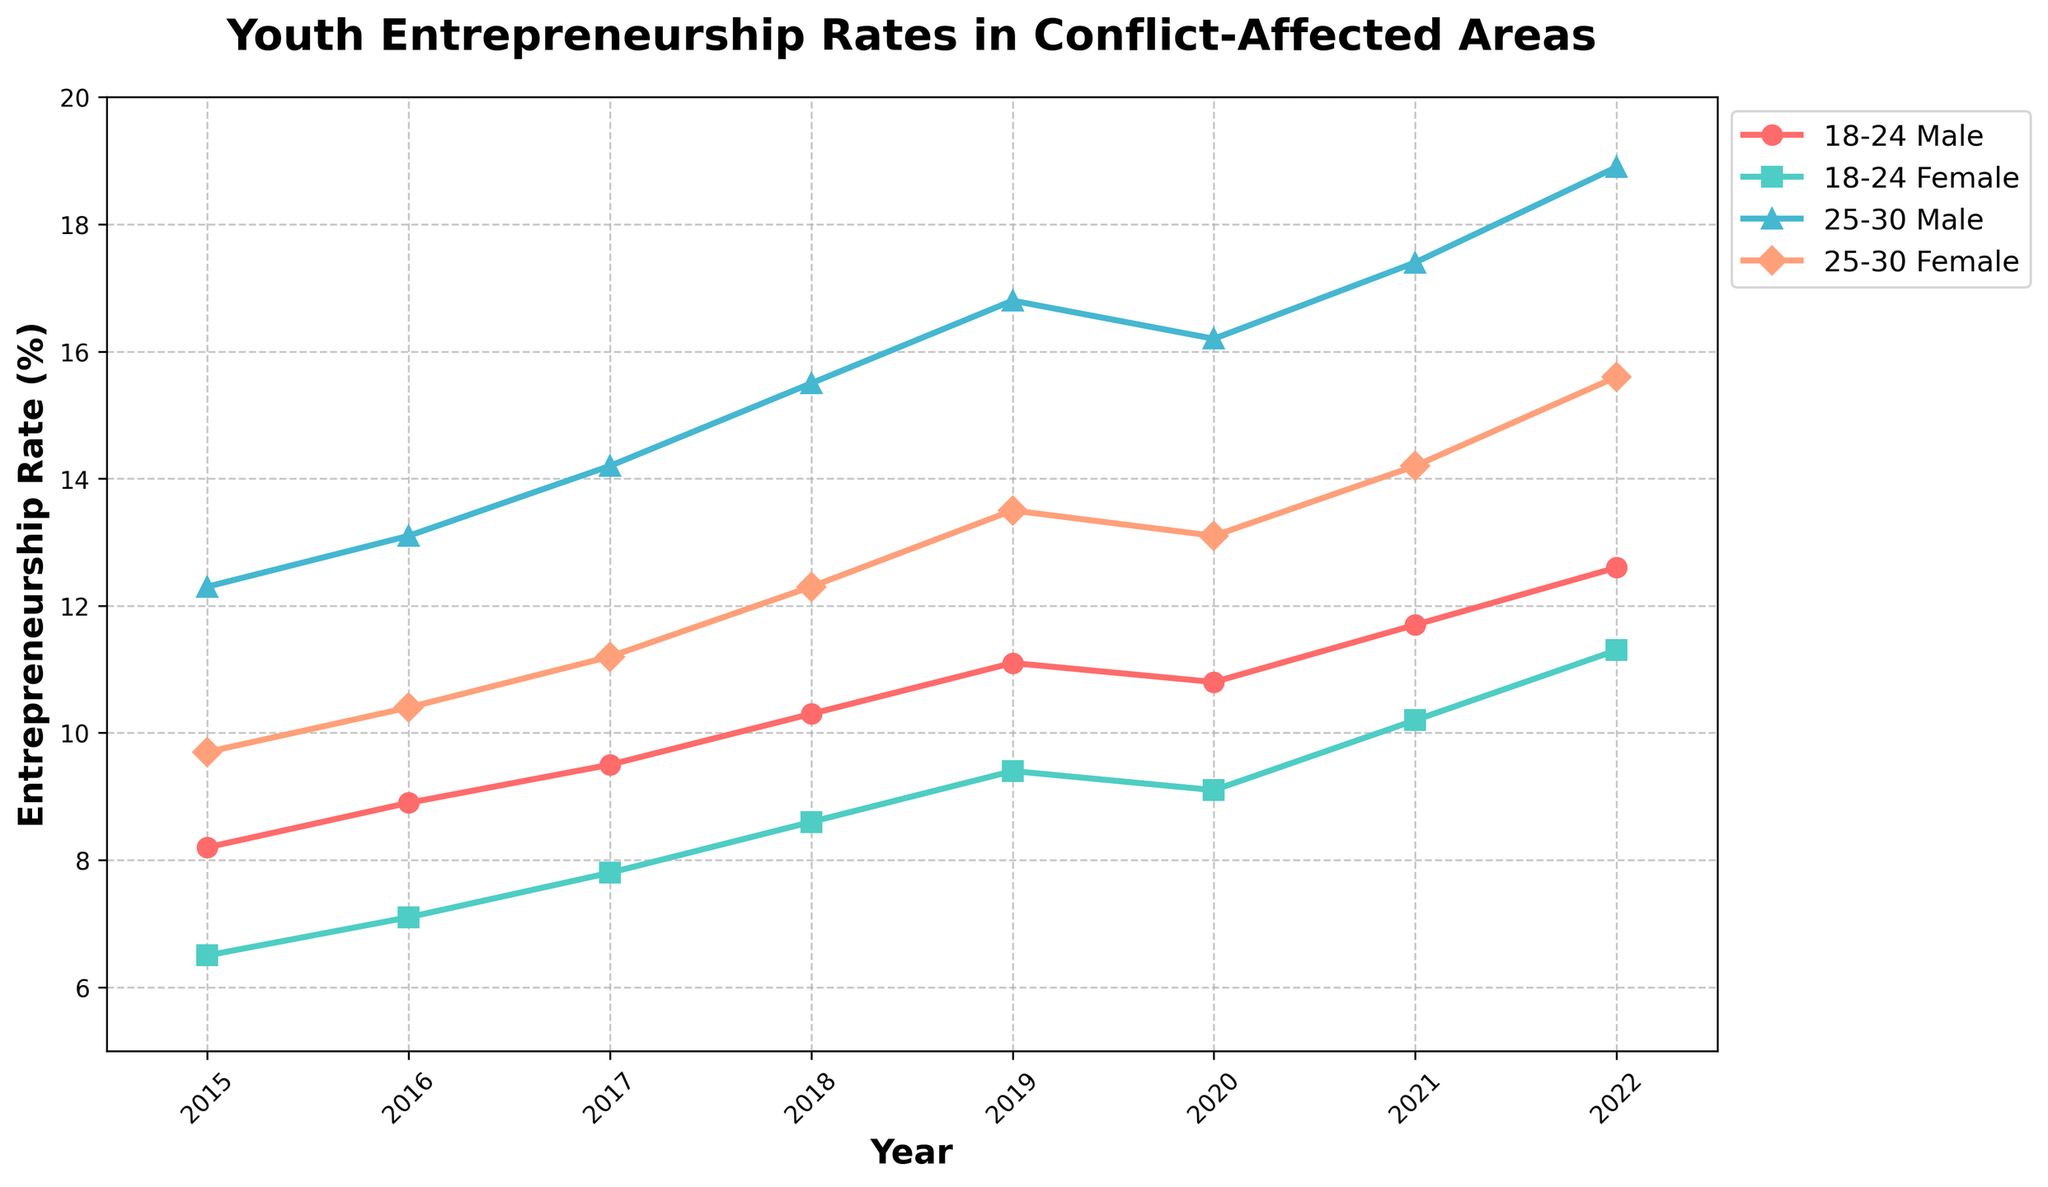What's the overall trend for male entrepreneurs aged 18-24 from 2015 to 2022? To answer this question, observe the line corresponding to "18-24 Male" from 2015 to 2022. It starts at 8.2 in 2015 and ends at 12.6 in 2022 with a general upward trend, despite a slight dip in 2020.
Answer: Upward trend In which year did 25-30 Female see the highest entrepreneurship rate? Look at the "25-30 Female" line and find the year with the highest point. The highest point is in 2022 with a rate of 15.6.
Answer: 2022 Compare the entrepreneurship rates of 18-24 Female and 25-30 Female in 2020. Which group had a higher rate and by how much? Locate the points for "18-24 Female" and "25-30 Female" in 2020. "18-24 Female" had a rate of 9.1 and "25-30 Female" had a rate of 13.1. The difference is 13.1 - 9.1 = 4.
Answer: 25-30 Female by 4 What is the rate of change in entrepreneurship for 25-30 Male from 2015 to 2022? Subtract the rate in 2015 (12.3) from the rate in 2022 (18.9). The difference is 18.9 - 12.3 = 6.6.
Answer: 6.6 Which group experienced the smallest change in entrepreneurship rates between 2019 and 2020? Calculate the difference from 2019 to 2020 for each group: 
18-24 Male: 11.1 to 10.8 = -0.3
18-24 Female: 9.4 to 9.1 = -0.3
25-30 Male: 16.8 to 16.2 = -0.6
25-30 Female: 13.5 to 13.1 = -0.4
The smallest change is -0.3.
Answer: 18-24 Male and 18-24 Female What was the entrepreneurship rate for 18-24 Female in the middle of the time period (around 2018)? Check the rate for "18-24 Female" in 2018. The value is 8.6.
Answer: 8.6 Between 2015 and 2022, which gender shows a more consistent increase in entrepreneurship rates in the 25-30 age group? Compare the "25-30 Male" and "25-30 Female" lines from 2015 to 2022. Both lines show an increase, but "25-30 Female" is smoother and shows less fluctuation compared to "25-30 Male".
Answer: Female Which group had the highest entrepreneurship rate in 2017? Identify the highest point in 2017 among all four lines. "25-30 Male" had the highest rate at 14.2.
Answer: 25-30 Male 